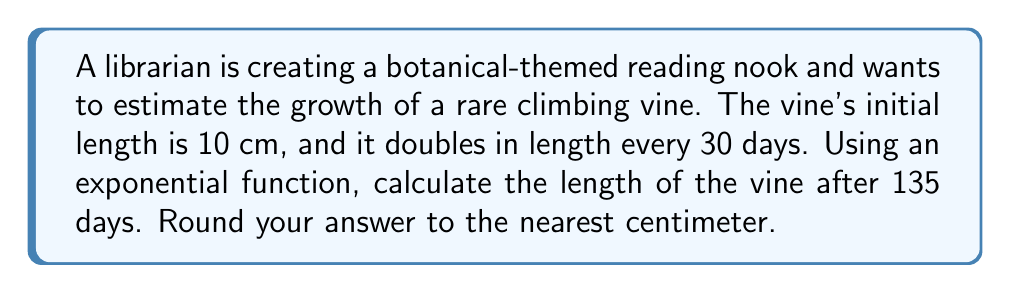Give your solution to this math problem. Let's approach this step-by-step:

1) First, we need to identify the components of our exponential function:
   - Initial length ($A_0$) = 10 cm
   - Growth rate: doubles every 30 days
   - Time (t) = 135 days

2) The general form of an exponential growth function is:
   $$ A(t) = A_0 \cdot b^t $$
   where $A_0$ is the initial amount, $b$ is the growth factor, and $t$ is time.

3) To find $b$, we need to consider that the plant doubles every 30 days:
   $$ 2 = b^{30} $$
   $$ b = 2^{\frac{1}{30}} \approx 1.0233 $$

4) Now, we need to adjust our time unit. Since $b$ is based on a 30-day period, we need to divide our total days by 30:
   $$ t = 135 \div 30 = 4.5 $$

5) Now we can plug everything into our exponential function:
   $$ A(4.5) = 10 \cdot (1.0233)^{4.5} $$

6) Calculate:
   $$ A(4.5) = 10 \cdot 1.1097 = 11.097 \text{ cm} $$

7) Rounding to the nearest centimeter:
   $$ A(4.5) \approx 11 \text{ cm} $$
Answer: 11 cm 